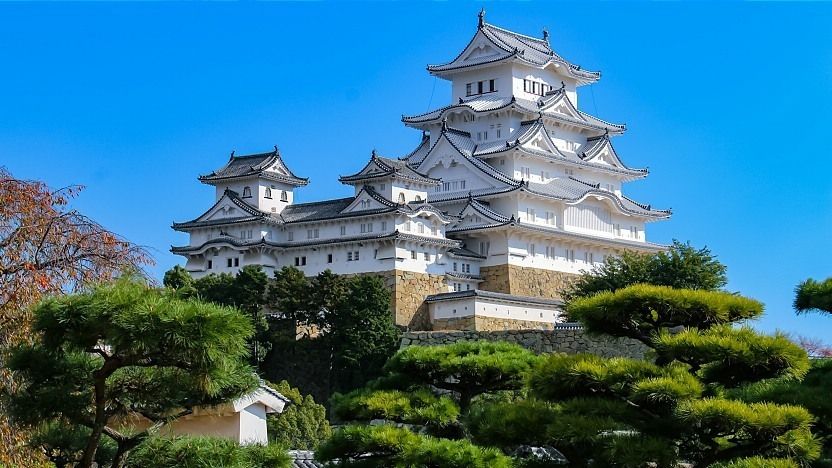Describe the significance of this castle in Japanese history. Himeji Castle, often referred to as the White Heron Castle due to its elegant, white appearance, is one of Japan's most significant historical landmarks. Built originally in 1333 and later expanded significantly in the early 1600s, it has survived wars, earthquakes, and the test of time, remaining one of the few original castles in Japan. It represents the finest example of Japanese castle architecture, embodying the principles of defensive design and aesthetics of the feudal period. As a UNESCO World Heritage Site, it stands as a symbol of Japan's cultural heritage, drawing millions of visitors who come to admire its beauty and historical importance. 